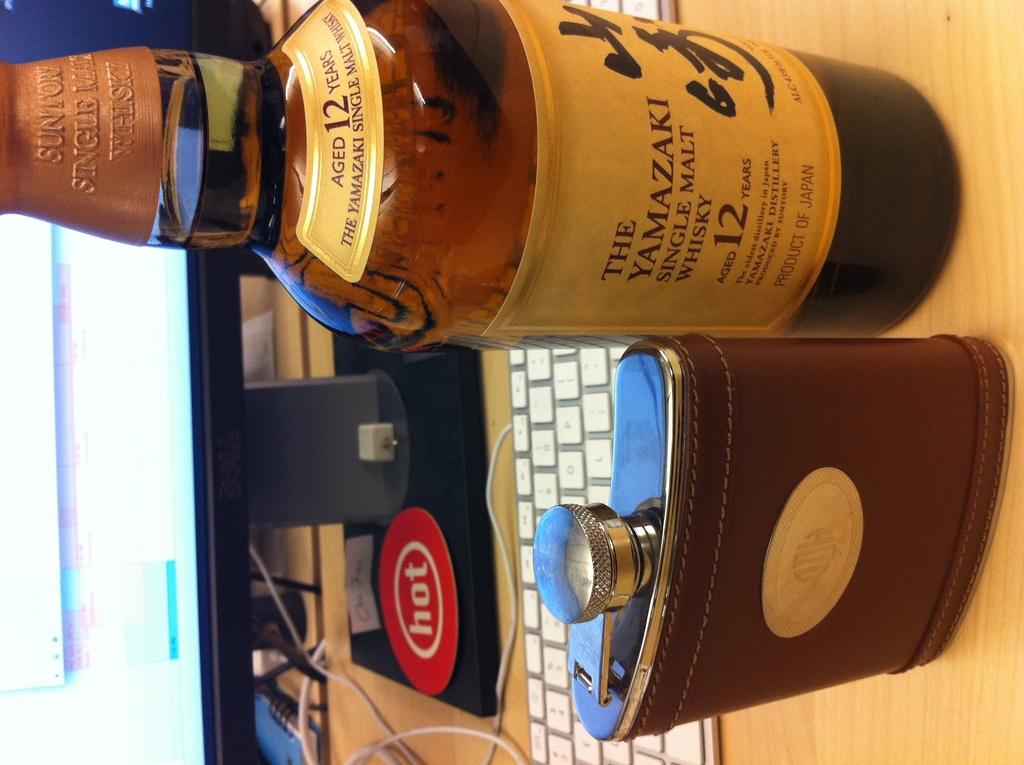What is on the table in the image? There is a wine bottle, a tin, a monitor, and a keyboard on the table. Can you describe the wine bottle? The wine bottle is on the table. What else is present on the table besides the wine bottle? There is a tin, a monitor, and a keyboard on the table. What might be used for typing or inputting commands in the image? The keyboard on the table can be used for typing or inputting commands. How does the credit system work in the image? There is no credit system present in the image; it features a wine bottle, a tin, a monitor, and a keyboard on a table. What type of carriage is used to transport the monitor in the image? There is no carriage present in the image; the monitor is on the table. 